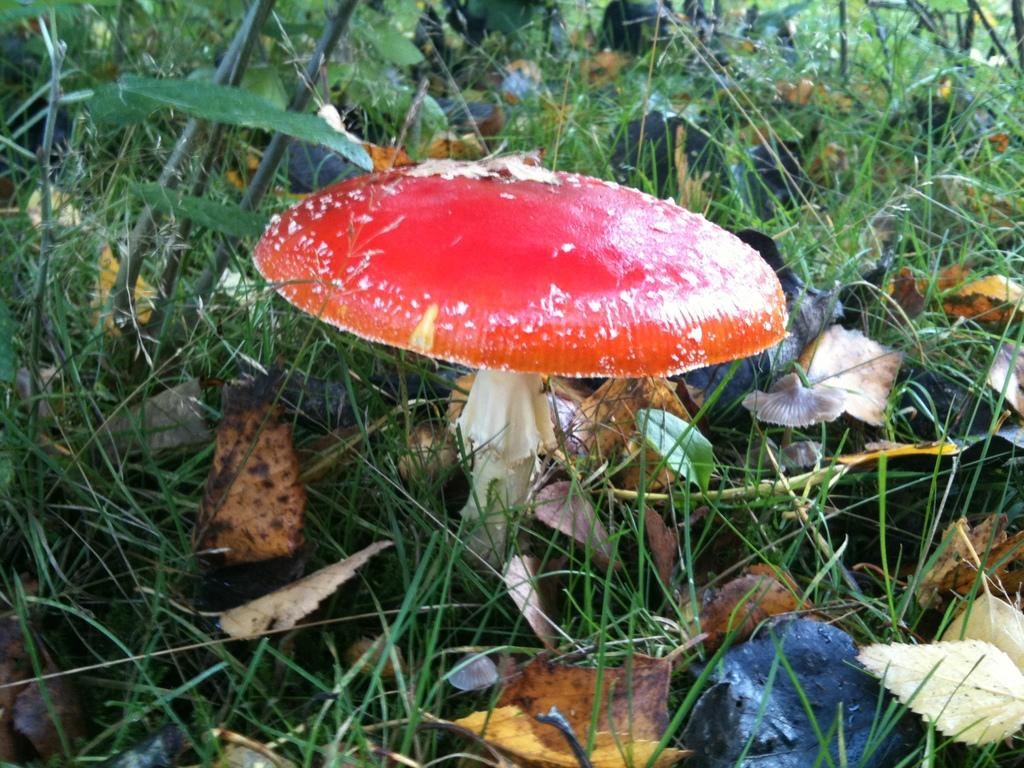What is the main subject in the center of the image? There is a mushroom in the center of the image. What can be seen in the background of the image? There are leaves and grass in the background of the image. How many bubbles are floating around the mushroom in the image? There are no bubbles present in the image; it features a mushroom and background elements of leaves and grass. 